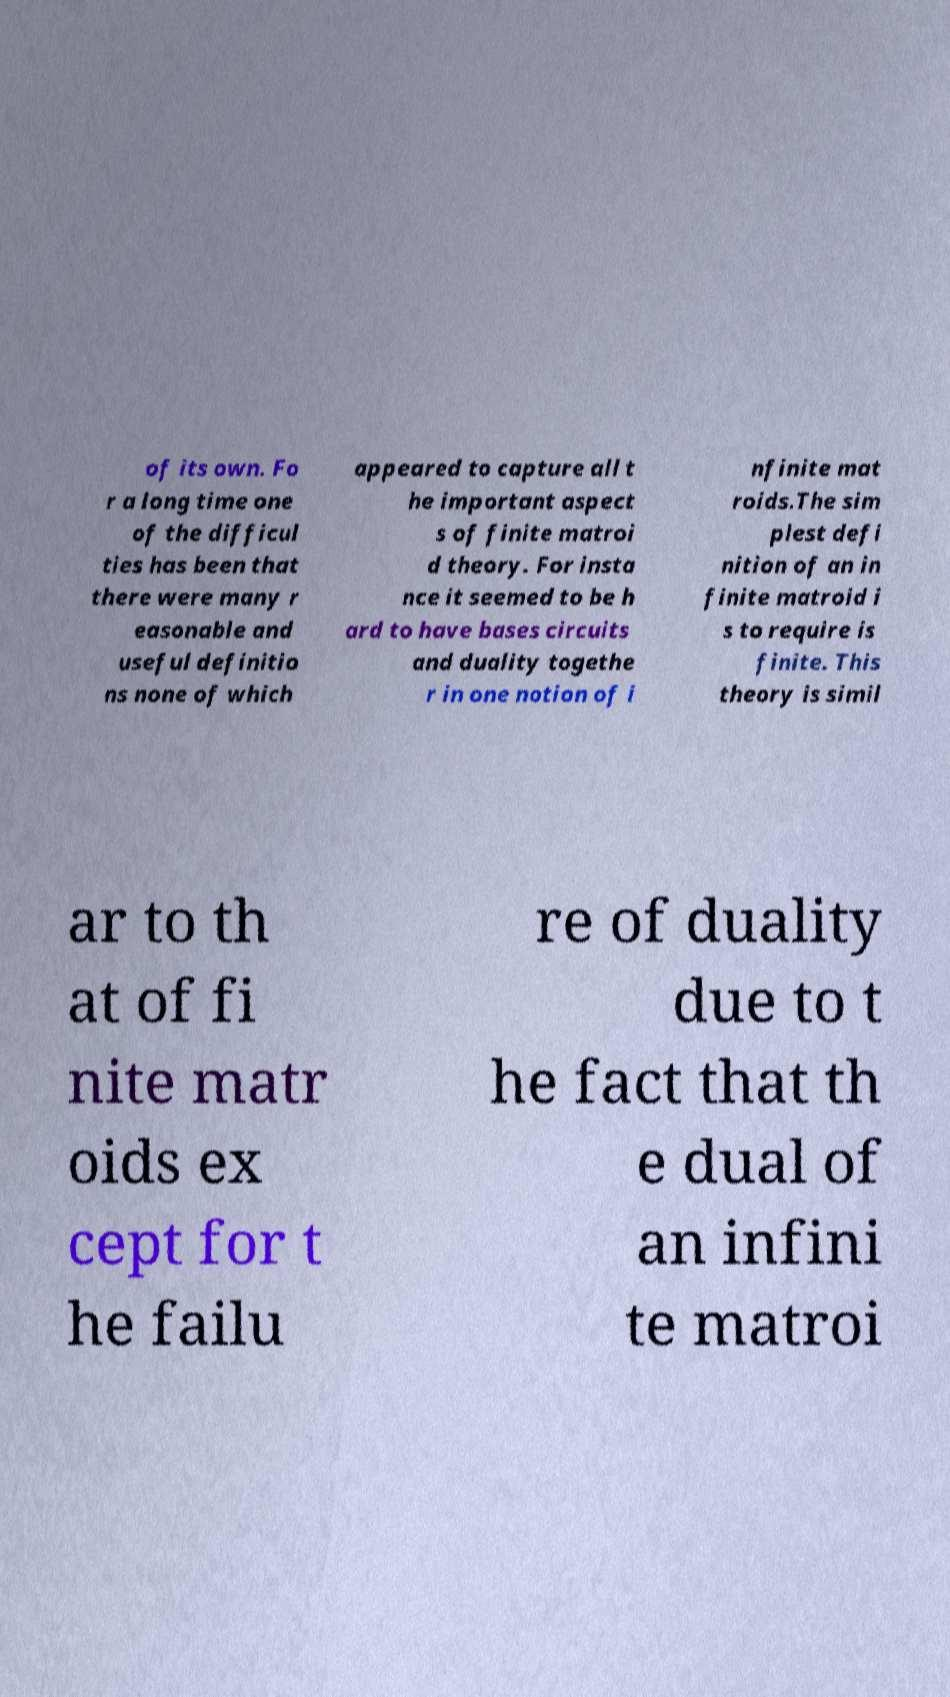Could you extract and type out the text from this image? of its own. Fo r a long time one of the difficul ties has been that there were many r easonable and useful definitio ns none of which appeared to capture all t he important aspect s of finite matroi d theory. For insta nce it seemed to be h ard to have bases circuits and duality togethe r in one notion of i nfinite mat roids.The sim plest defi nition of an in finite matroid i s to require is finite. This theory is simil ar to th at of fi nite matr oids ex cept for t he failu re of duality due to t he fact that th e dual of an infini te matroi 